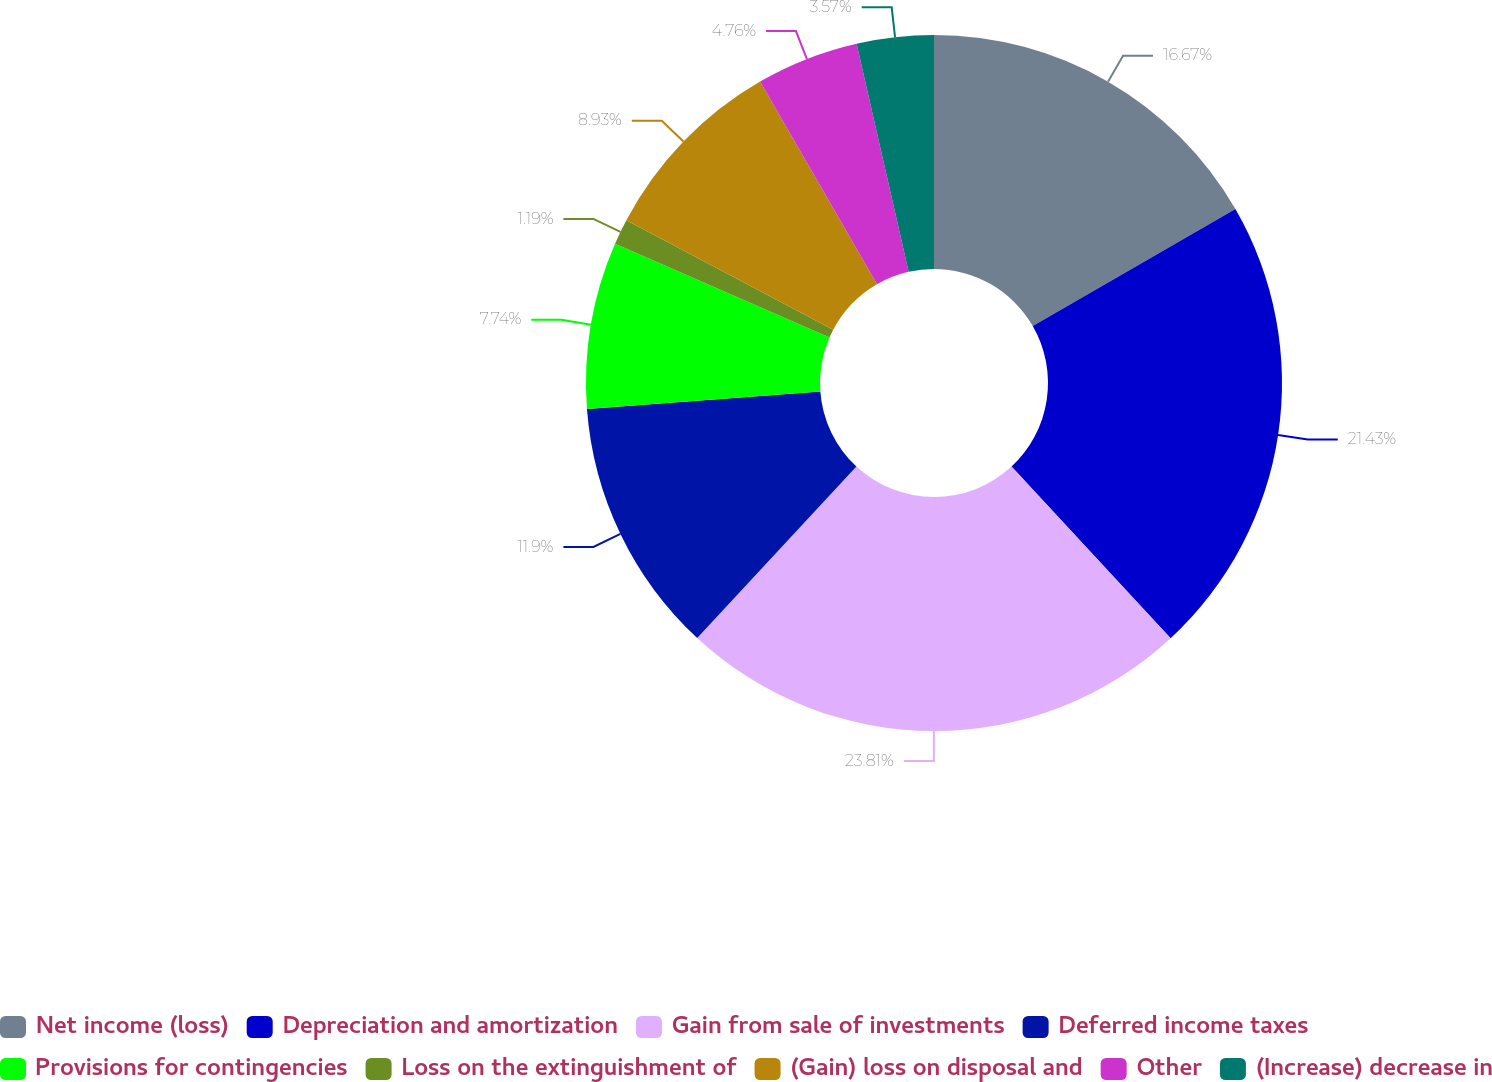Convert chart. <chart><loc_0><loc_0><loc_500><loc_500><pie_chart><fcel>Net income (loss)<fcel>Depreciation and amortization<fcel>Gain from sale of investments<fcel>Deferred income taxes<fcel>Provisions for contingencies<fcel>Loss on the extinguishment of<fcel>(Gain) loss on disposal and<fcel>Other<fcel>(Increase) decrease in<nl><fcel>16.67%<fcel>21.43%<fcel>23.81%<fcel>11.9%<fcel>7.74%<fcel>1.19%<fcel>8.93%<fcel>4.76%<fcel>3.57%<nl></chart> 